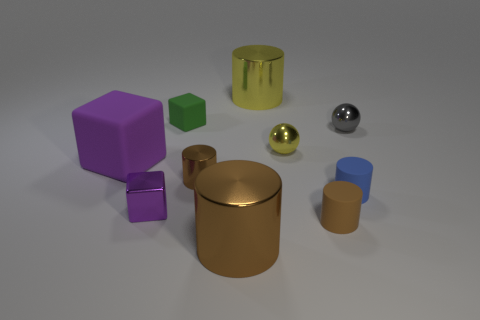Subtract all purple blocks. How many brown cylinders are left? 3 Subtract all blue cylinders. How many cylinders are left? 4 Subtract all small metal cylinders. How many cylinders are left? 4 Subtract all cyan cylinders. Subtract all green cubes. How many cylinders are left? 5 Subtract all cubes. How many objects are left? 7 Add 6 big purple objects. How many big purple objects exist? 7 Subtract 0 red spheres. How many objects are left? 10 Subtract all large yellow shiny cylinders. Subtract all shiny objects. How many objects are left? 3 Add 7 big yellow cylinders. How many big yellow cylinders are left? 8 